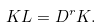Convert formula to latex. <formula><loc_0><loc_0><loc_500><loc_500>K L = D ^ { r } K .</formula> 